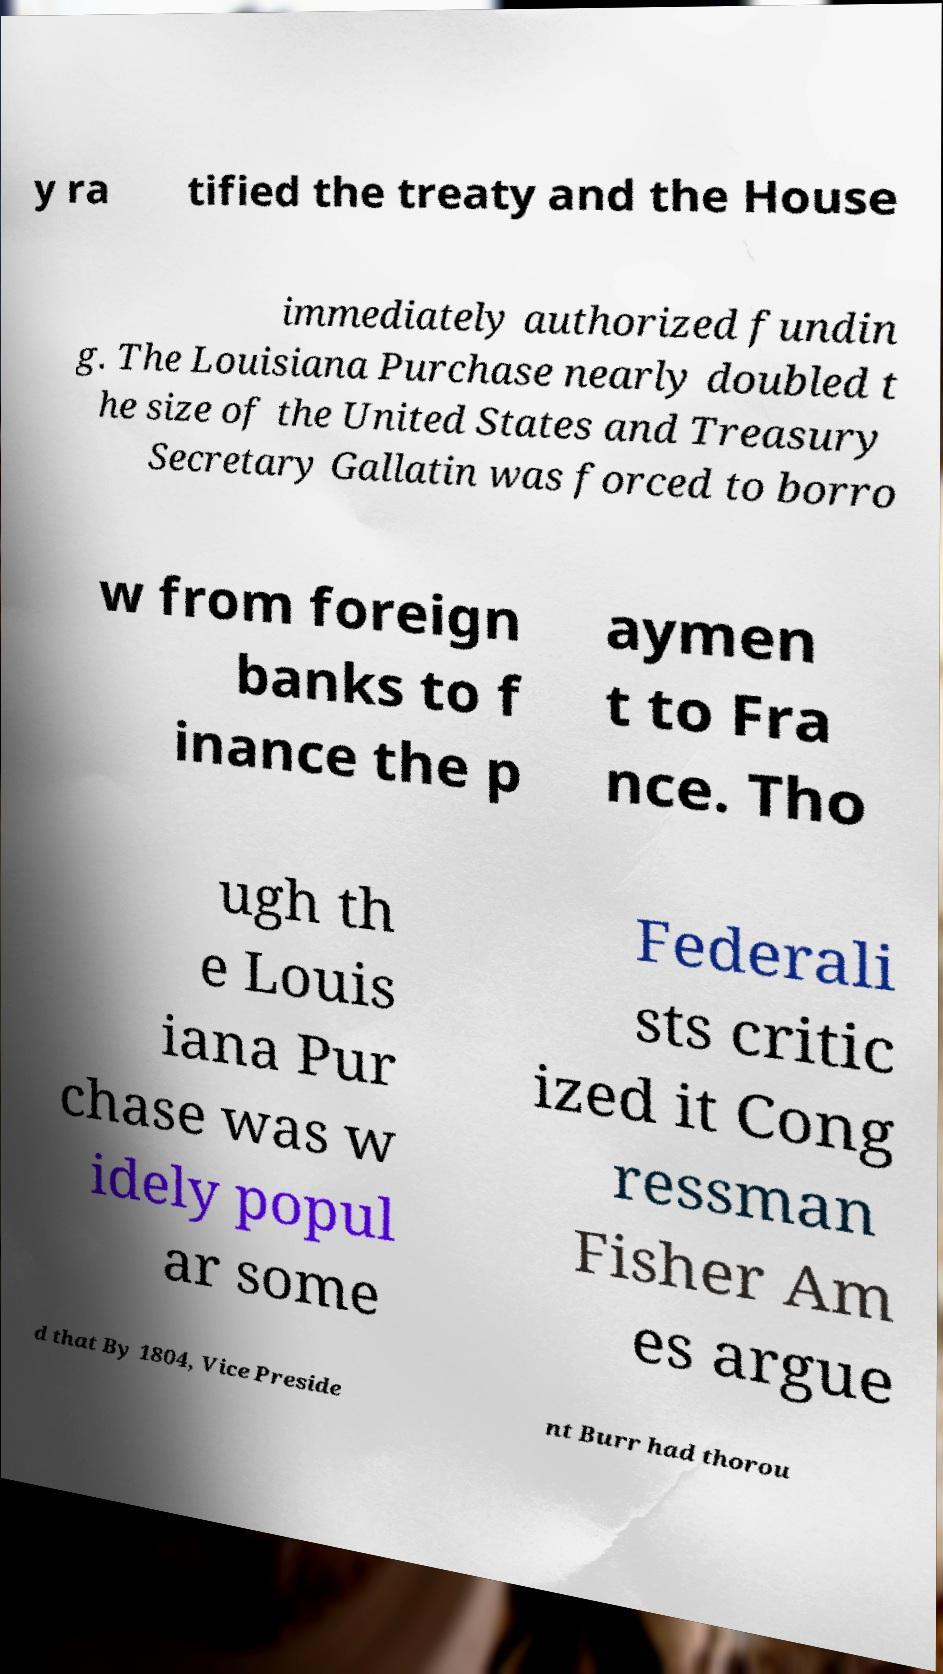Can you read and provide the text displayed in the image?This photo seems to have some interesting text. Can you extract and type it out for me? y ra tified the treaty and the House immediately authorized fundin g. The Louisiana Purchase nearly doubled t he size of the United States and Treasury Secretary Gallatin was forced to borro w from foreign banks to f inance the p aymen t to Fra nce. Tho ugh th e Louis iana Pur chase was w idely popul ar some Federali sts critic ized it Cong ressman Fisher Am es argue d that By 1804, Vice Preside nt Burr had thorou 